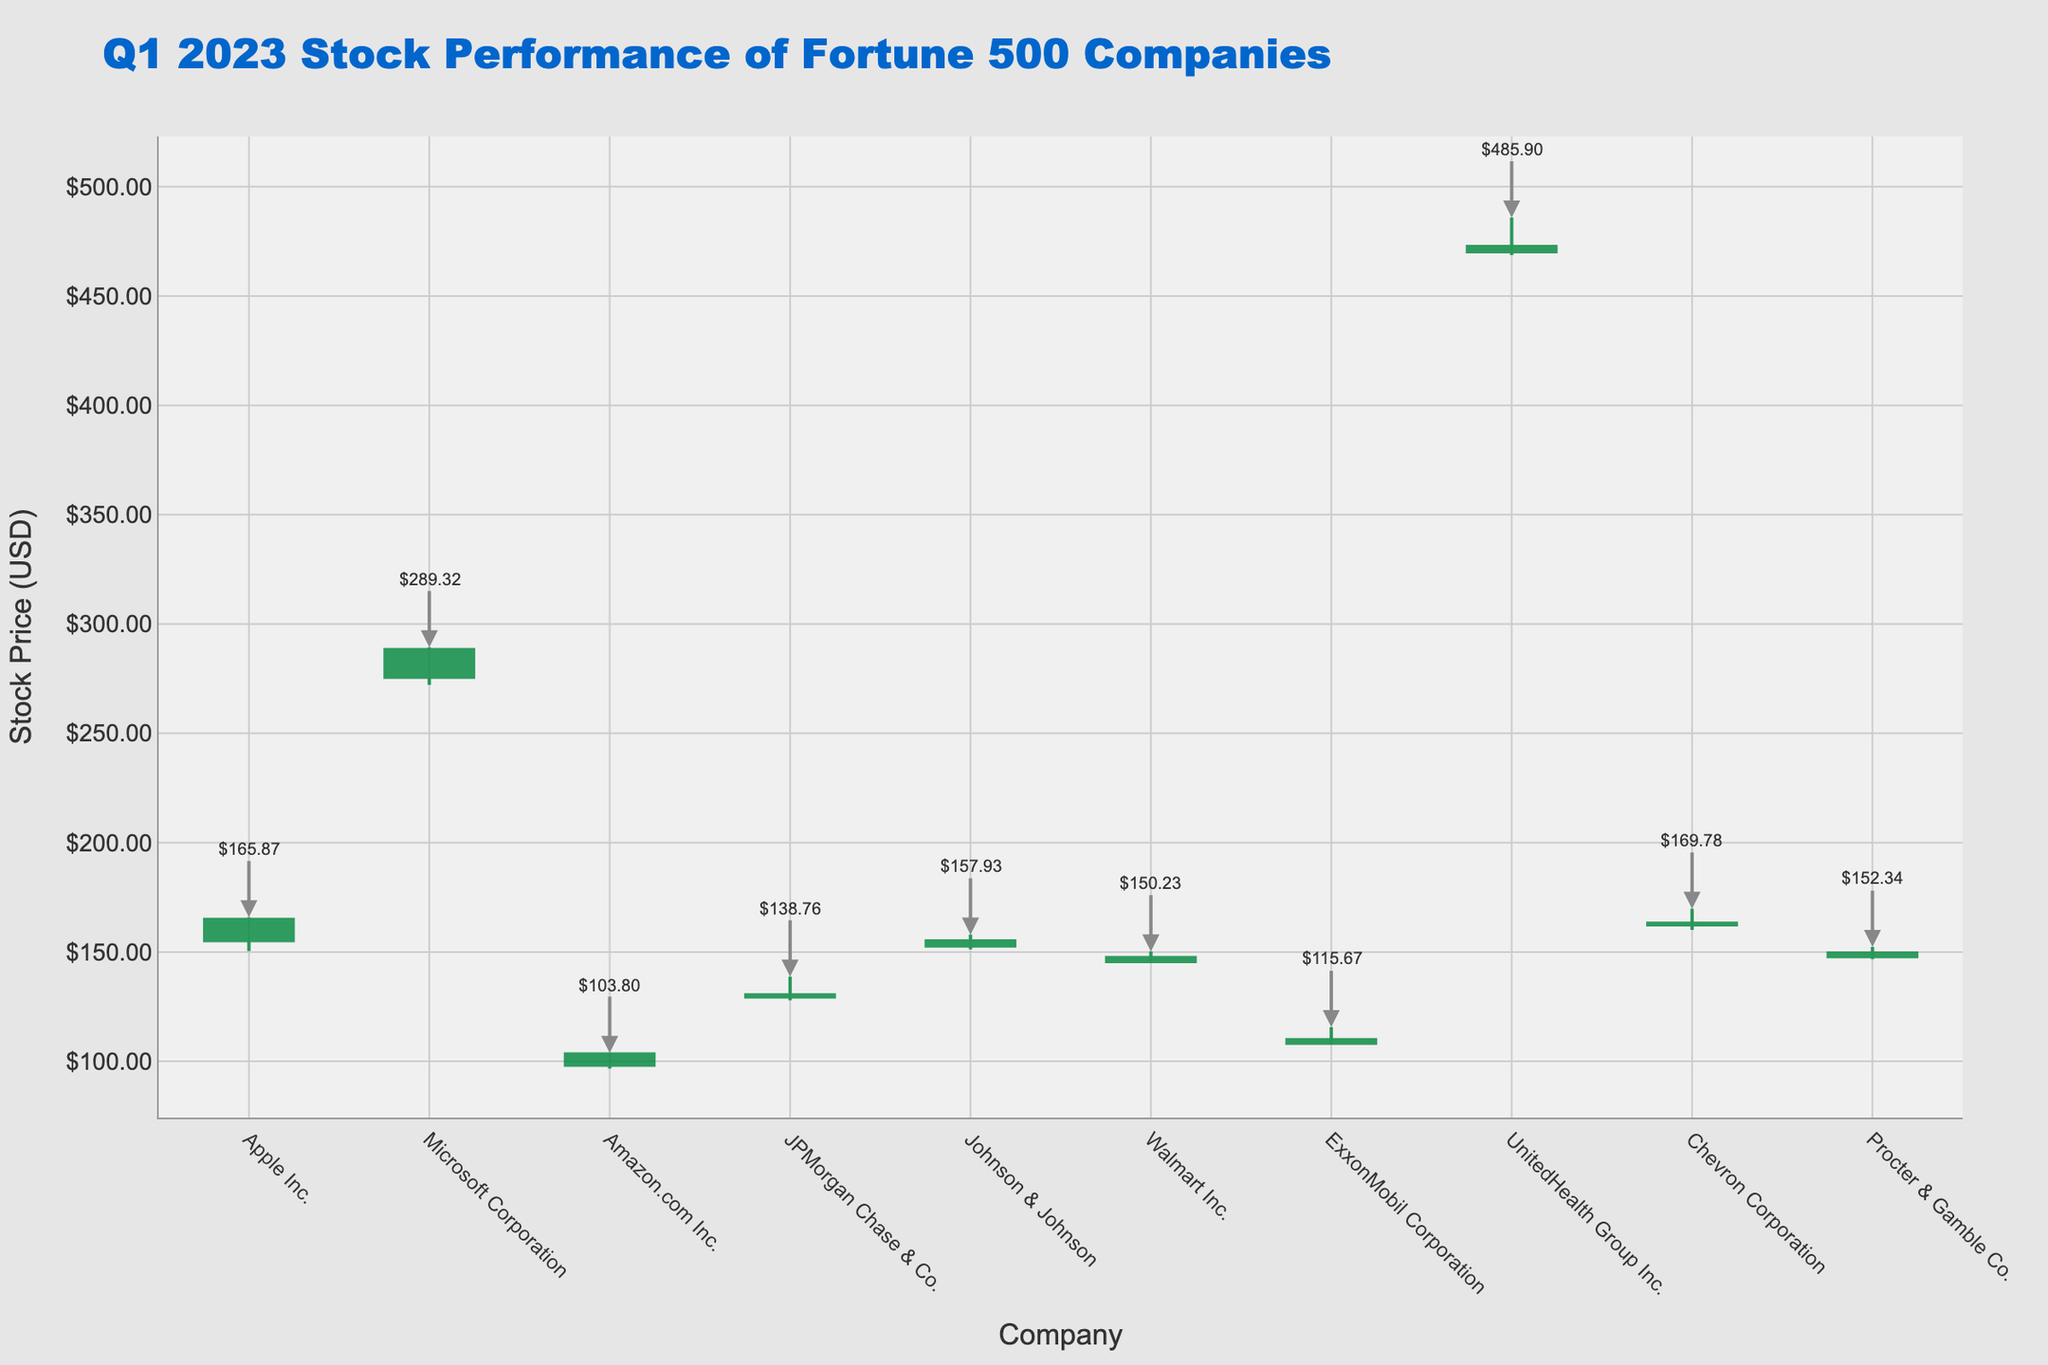What's the title of the chart? The title is found at the top of the figure and usually summarizes the content of the chart. In this case, it reads, "Q1 2023 Stock Performance of Fortune 500 Companies".
Answer: Q1 2023 Stock Performance of Fortune 500 Companies Which company had the highest closing price? By looking at the closing price for each company's stock, it's evident that Microsoft Corporation had the highest closing price at $288.30.
Answer: Microsoft Corporation What is the range of Walmart Inc.'s stock price? The range is calculated by subtracting the low price from the high price. For Walmart Inc., it's $150.23 (high) - $144.89 (low) = $5.34.
Answer: $5.34 How many companies' stocks closed higher than they opened? For each company, compare the closing price to the opening price. Apple Inc., Microsoft Corporation, Amazon.com Inc., and Procter & Gamble Co. closed higher than they opened.
Answer: 4 Which company had the smallest difference between its highest and lowest stock prices? Calculate the difference between the high and low prices for each company. Johnson & Johnson has the smallest difference ($157.93 - $151.22 = $6.71).
Answer: Johnson & Johnson Which company's stock price had the largest increase from open to close? Subtract the opening price from the closing price for each company and compare the differences. Microsoft Corporation had the largest increase ($288.30 - $275.68 = $12.62).
Answer: Microsoft Corporation What was the closing price for ExxonMobil Corporation? The closing price for each company is displayed. For ExxonMobil Corporation, it is $109.83.
Answer: $109.83 Which company had the lowest high stock price? Look at the highest stock prices for each company and identify the lowest one. Amazon.com Inc. had the lowest high stock price at $103.80.
Answer: Amazon.com Inc What is the average closing price of these companies? Sum the closing prices ($164.90 + $288.30 + $103.29 + $130.31 + $155.00 + $147.45 + $109.83 + $472.59 + $163.16 + $149.51) and divide by the number of companies (10). The average is $1784.34 / 10 = $178.43.
Answer: $178.43 Is there any company whose stock closed at its highest price of the period? By checking the closing prices against the highest prices, none of the companies closed at their highest price.
Answer: No 